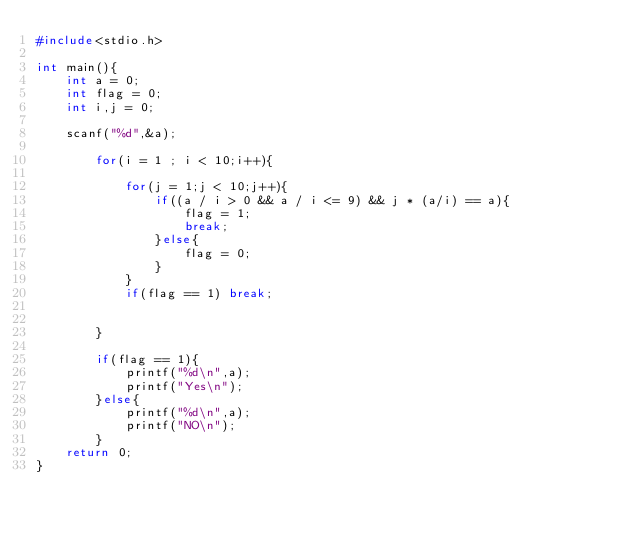<code> <loc_0><loc_0><loc_500><loc_500><_C_>#include<stdio.h>

int main(){
	int a = 0;
	int flag = 0;
	int i,j = 0;

	scanf("%d",&a);

		for(i = 1 ; i < 10;i++){

			for(j = 1;j < 10;j++){
				if((a / i > 0 && a / i <= 9) && j * (a/i) == a){
					flag = 1;
					break;
				}else{
					flag = 0;
				}
			}
			if(flag == 1) break;


		}

		if(flag == 1){
			printf("%d\n",a);
			printf("Yes\n");
		}else{
			printf("%d\n",a);
			printf("NO\n");
		}
	return 0;
}
</code> 